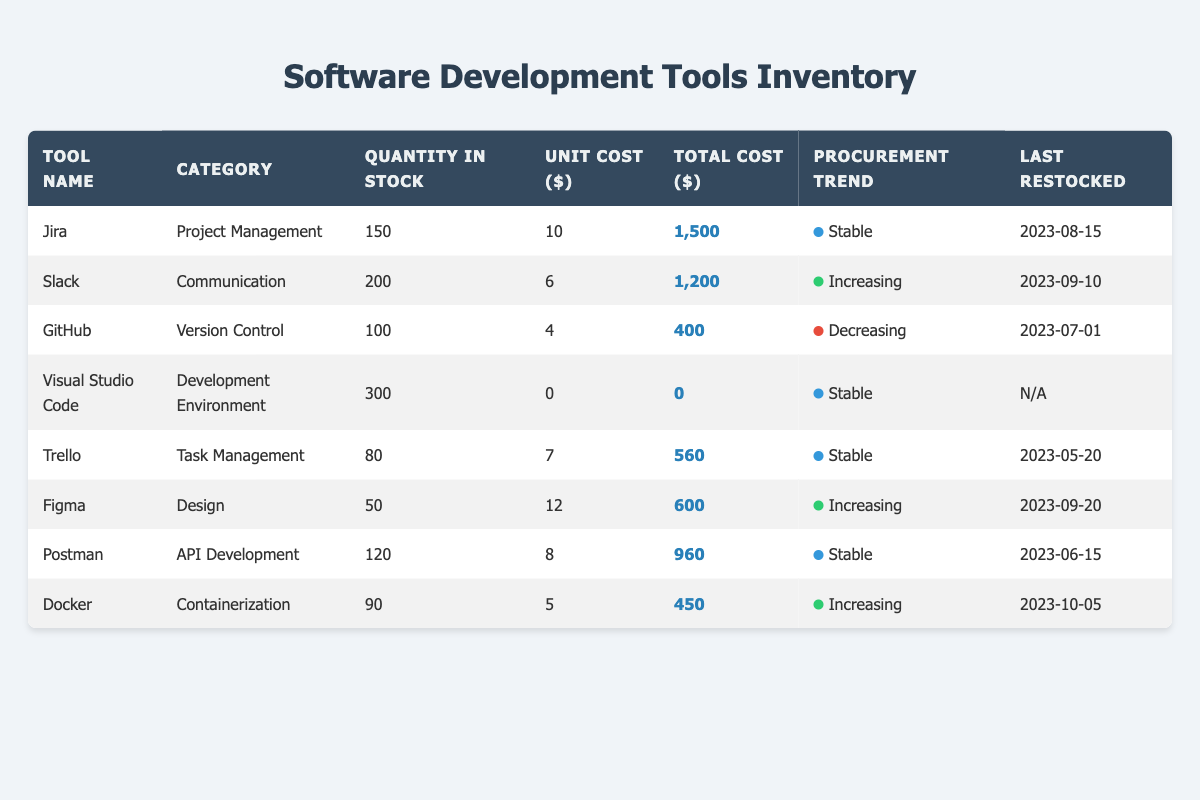What is the total cost of the tools in stock? To find the total cost of the tools in stock, sum the total costs: 1500 + 1200 + 400 + 0 + 560 + 600 + 960 + 450 = 4360.
Answer: 4360 Which tool category has the highest quantity in stock? The tool categories are compared based on their quantities: Project Management (150), Communication (200), Version Control (100), Development Environment (300), Task Management (80), Design (50), API Development (120), and Containerization (90). The Development Environment category has the highest quantity at 300.
Answer: Development Environment Is GitHub's procurement trend stable? The procurement trend for GitHub is listed as "Decreasing," which is not stable.
Answer: No What is the unit cost of the tool with the lowest total cost? The tool with the lowest total cost is GitHub with a total of 400. The unit cost for GitHub is 4.
Answer: 4 How many tools have an increasing procurement trend? The tools with increasing procurement trends are Slack, Figma, and Docker. There are three tools that fall into this category.
Answer: 3 What is the average unit cost of all tools in stock? The unit costs are 10, 6, 4, 0, 7, 12, 8, and 5. We first sum these values: 10 + 6 + 4 + 0 + 7 + 12 + 8 + 5 = 52. There are 8 tools, so the average unit cost is 52 / 8 = 6.5.
Answer: 6.5 Which tool was last restocked most recently? The last restocked dates for the tools are: Jira (2023-08-15), Slack (2023-09-10), GitHub (2023-07-01), Visual Studio Code (N/A), Trello (2023-05-20), Figma (2023-09-20), Postman (2023-06-15), Docker (2023-10-05). The most recent date is Docker's, 2023-10-05.
Answer: Docker What is the total quantity of tools in stable procurement trends? The tools with stable procurement trends are Jira (150), Visual Studio Code (300), Trello (80), and Postman (120). The total quantity is: 150 + 300 + 80 + 120 = 650.
Answer: 650 